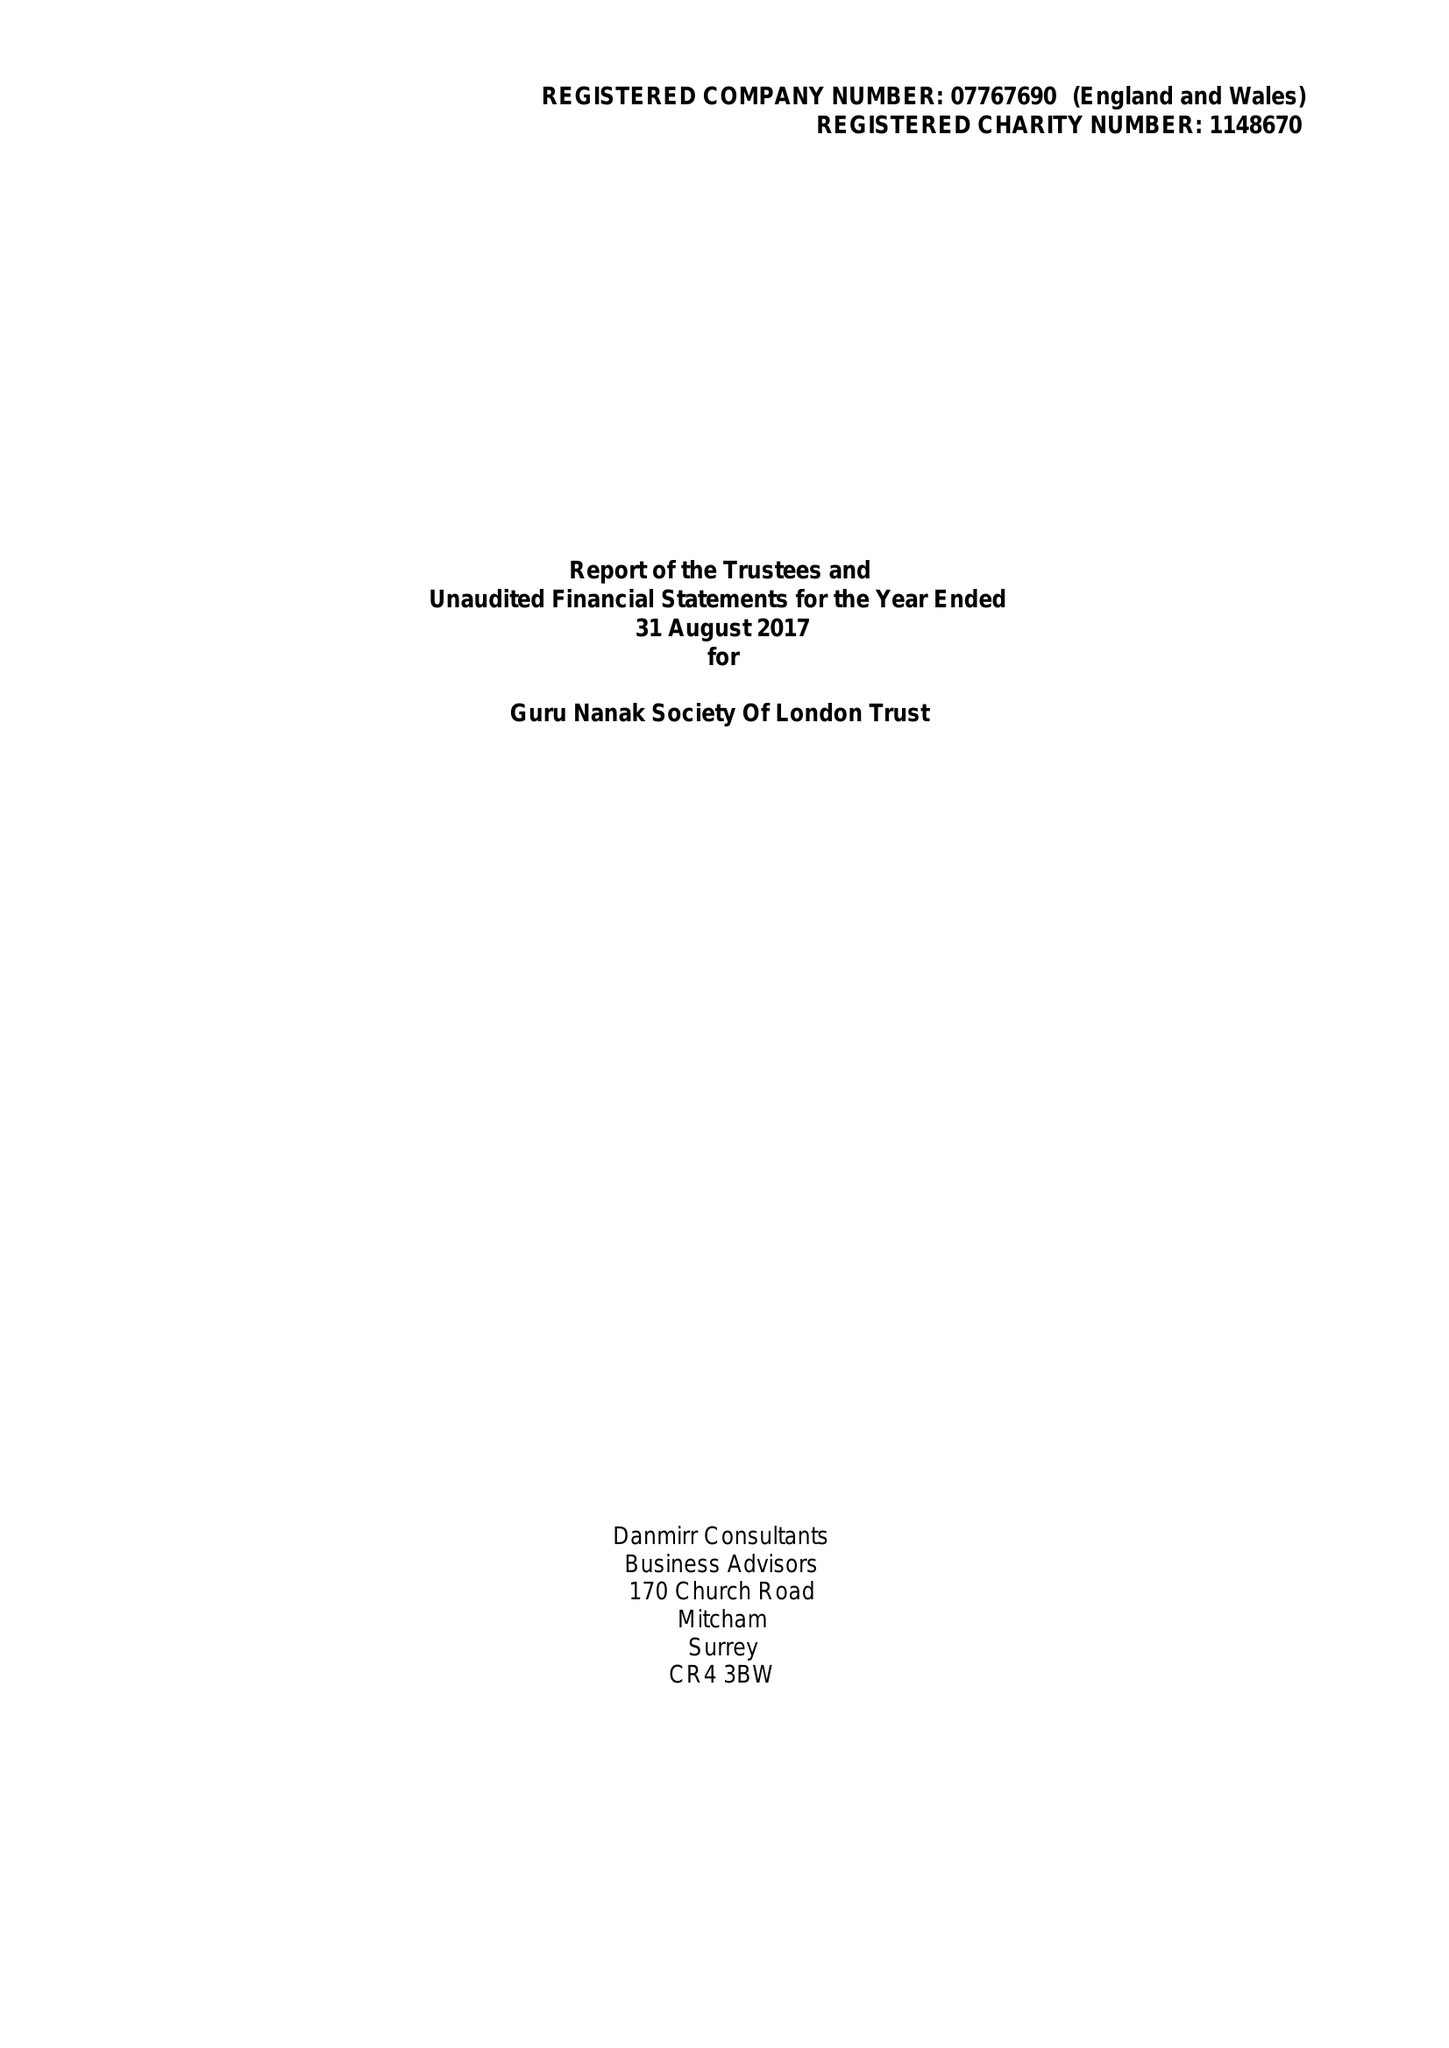What is the value for the address__postcode?
Answer the question using a single word or phrase. UB2 4BD 